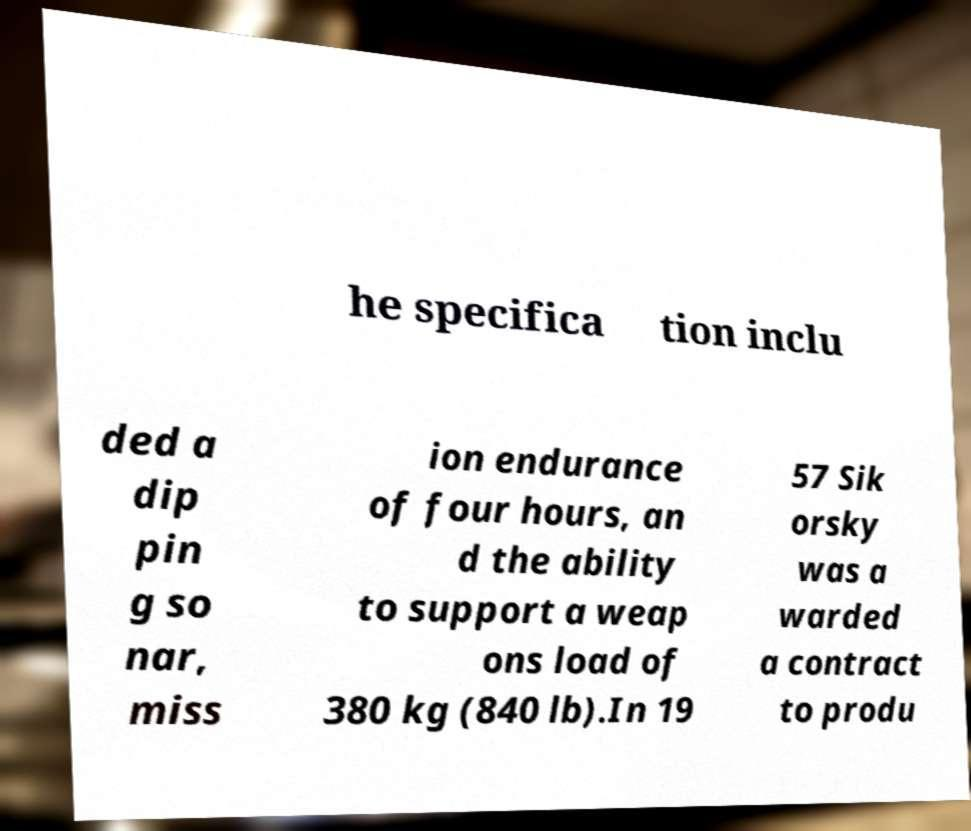Can you accurately transcribe the text from the provided image for me? he specifica tion inclu ded a dip pin g so nar, miss ion endurance of four hours, an d the ability to support a weap ons load of 380 kg (840 lb).In 19 57 Sik orsky was a warded a contract to produ 